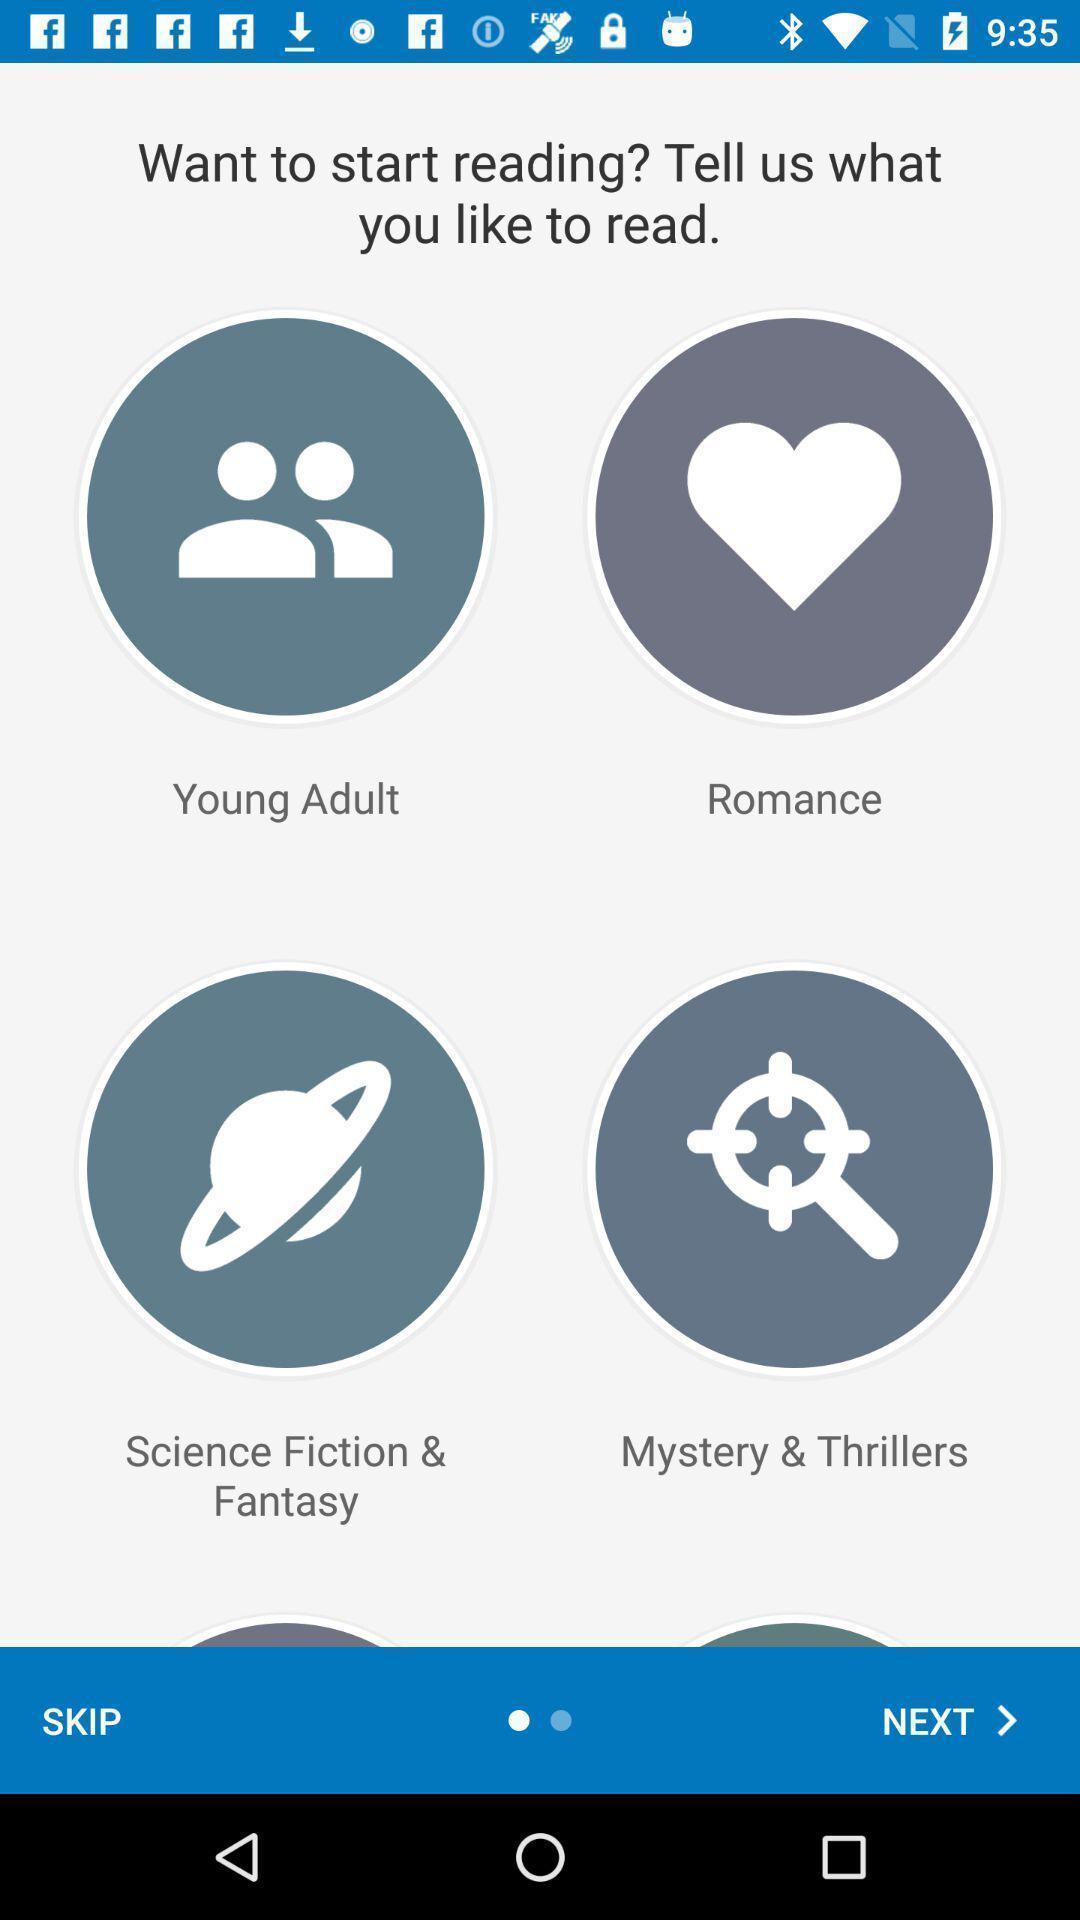Provide a textual representation of this image. Page describing the categories of the app. 